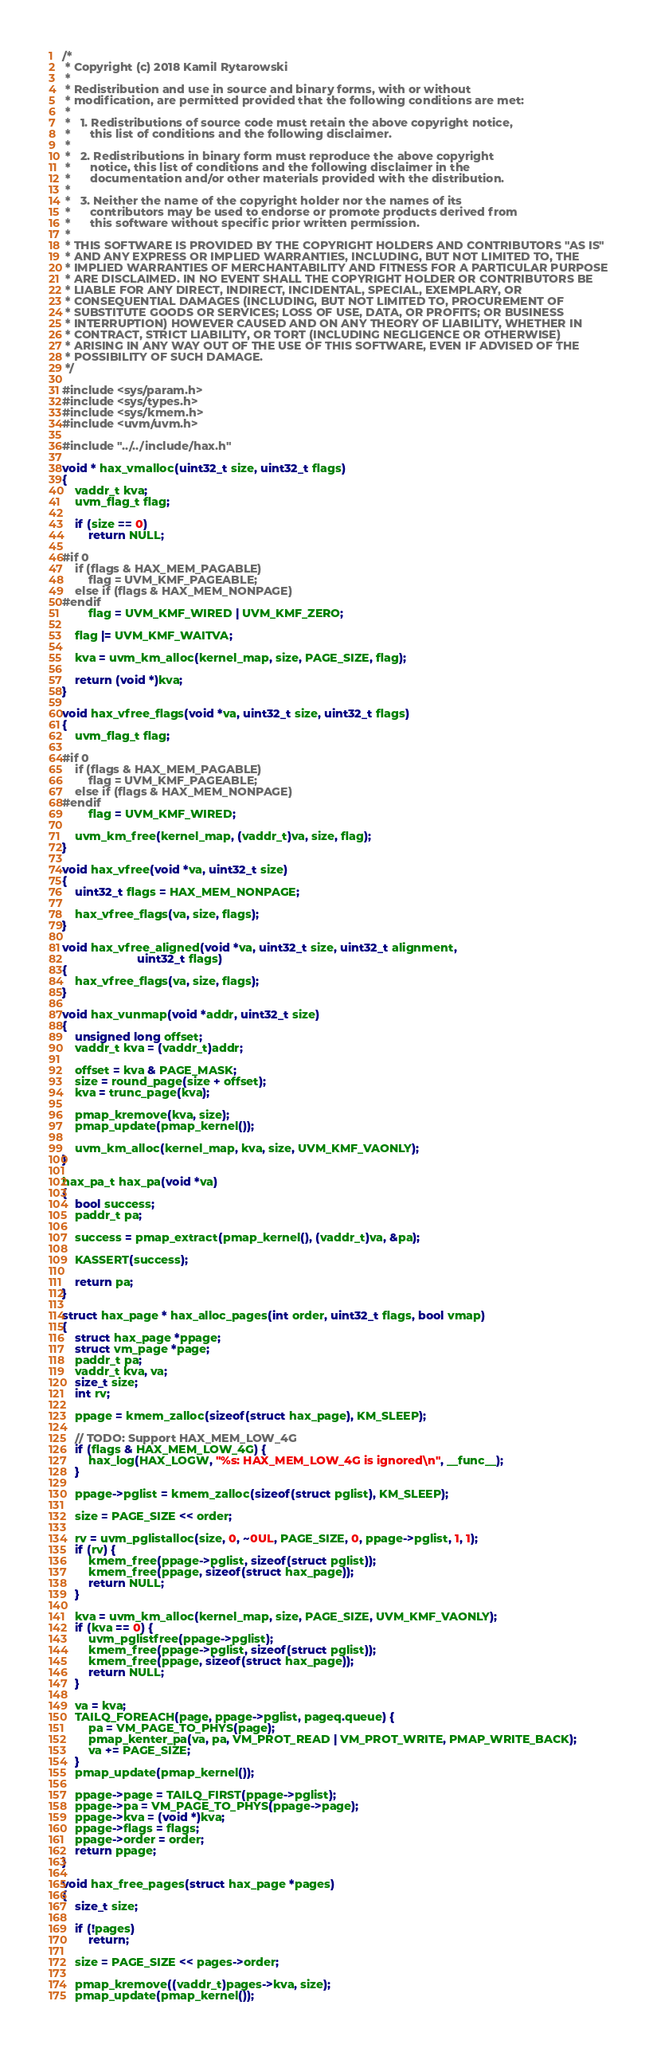Convert code to text. <code><loc_0><loc_0><loc_500><loc_500><_C_>/*
 * Copyright (c) 2018 Kamil Rytarowski
 *
 * Redistribution and use in source and binary forms, with or without
 * modification, are permitted provided that the following conditions are met:
 *
 *   1. Redistributions of source code must retain the above copyright notice,
 *      this list of conditions and the following disclaimer.
 *
 *   2. Redistributions in binary form must reproduce the above copyright
 *      notice, this list of conditions and the following disclaimer in the
 *      documentation and/or other materials provided with the distribution.
 *
 *   3. Neither the name of the copyright holder nor the names of its
 *      contributors may be used to endorse or promote products derived from
 *      this software without specific prior written permission.
 *
 * THIS SOFTWARE IS PROVIDED BY THE COPYRIGHT HOLDERS AND CONTRIBUTORS "AS IS"
 * AND ANY EXPRESS OR IMPLIED WARRANTIES, INCLUDING, BUT NOT LIMITED TO, THE
 * IMPLIED WARRANTIES OF MERCHANTABILITY AND FITNESS FOR A PARTICULAR PURPOSE
 * ARE DISCLAIMED. IN NO EVENT SHALL THE COPYRIGHT HOLDER OR CONTRIBUTORS BE
 * LIABLE FOR ANY DIRECT, INDIRECT, INCIDENTAL, SPECIAL, EXEMPLARY, OR
 * CONSEQUENTIAL DAMAGES (INCLUDING, BUT NOT LIMITED TO, PROCUREMENT OF
 * SUBSTITUTE GOODS OR SERVICES; LOSS OF USE, DATA, OR PROFITS; OR BUSINESS
 * INTERRUPTION) HOWEVER CAUSED AND ON ANY THEORY OF LIABILITY, WHETHER IN
 * CONTRACT, STRICT LIABILITY, OR TORT (INCLUDING NEGLIGENCE OR OTHERWISE)
 * ARISING IN ANY WAY OUT OF THE USE OF THIS SOFTWARE, EVEN IF ADVISED OF THE
 * POSSIBILITY OF SUCH DAMAGE.
 */

#include <sys/param.h>
#include <sys/types.h>
#include <sys/kmem.h>
#include <uvm/uvm.h>

#include "../../include/hax.h"

void * hax_vmalloc(uint32_t size, uint32_t flags)
{
    vaddr_t kva;
    uvm_flag_t flag;

    if (size == 0)
        return NULL;

#if 0
    if (flags & HAX_MEM_PAGABLE)
        flag = UVM_KMF_PAGEABLE;
    else if (flags & HAX_MEM_NONPAGE)
#endif
        flag = UVM_KMF_WIRED | UVM_KMF_ZERO;

    flag |= UVM_KMF_WAITVA;

    kva = uvm_km_alloc(kernel_map, size, PAGE_SIZE, flag);

    return (void *)kva;
}

void hax_vfree_flags(void *va, uint32_t size, uint32_t flags)
{
    uvm_flag_t flag;

#if 0
    if (flags & HAX_MEM_PAGABLE)
        flag = UVM_KMF_PAGEABLE;
    else if (flags & HAX_MEM_NONPAGE)
#endif
        flag = UVM_KMF_WIRED;

    uvm_km_free(kernel_map, (vaddr_t)va, size, flag);
}

void hax_vfree(void *va, uint32_t size)
{
    uint32_t flags = HAX_MEM_NONPAGE;

    hax_vfree_flags(va, size, flags);
}

void hax_vfree_aligned(void *va, uint32_t size, uint32_t alignment,
                       uint32_t flags)
{
    hax_vfree_flags(va, size, flags);
}

void hax_vunmap(void *addr, uint32_t size)
{
    unsigned long offset;
    vaddr_t kva = (vaddr_t)addr;

    offset = kva & PAGE_MASK;
    size = round_page(size + offset);
    kva = trunc_page(kva);

    pmap_kremove(kva, size);
    pmap_update(pmap_kernel());

    uvm_km_alloc(kernel_map, kva, size, UVM_KMF_VAONLY);
}

hax_pa_t hax_pa(void *va)
{
    bool success;
    paddr_t pa;

    success = pmap_extract(pmap_kernel(), (vaddr_t)va, &pa);

    KASSERT(success);

    return pa;
}

struct hax_page * hax_alloc_pages(int order, uint32_t flags, bool vmap)
{
    struct hax_page *ppage;
    struct vm_page *page;
    paddr_t pa;
    vaddr_t kva, va;
    size_t size;
    int rv;

    ppage = kmem_zalloc(sizeof(struct hax_page), KM_SLEEP);

    // TODO: Support HAX_MEM_LOW_4G
    if (flags & HAX_MEM_LOW_4G) {
        hax_log(HAX_LOGW, "%s: HAX_MEM_LOW_4G is ignored\n", __func__);
    }

    ppage->pglist = kmem_zalloc(sizeof(struct pglist), KM_SLEEP);

    size = PAGE_SIZE << order;

    rv = uvm_pglistalloc(size, 0, ~0UL, PAGE_SIZE, 0, ppage->pglist, 1, 1);
    if (rv) {
        kmem_free(ppage->pglist, sizeof(struct pglist));
        kmem_free(ppage, sizeof(struct hax_page));
        return NULL;
    }

    kva = uvm_km_alloc(kernel_map, size, PAGE_SIZE, UVM_KMF_VAONLY);
    if (kva == 0) {
        uvm_pglistfree(ppage->pglist);
        kmem_free(ppage->pglist, sizeof(struct pglist));
        kmem_free(ppage, sizeof(struct hax_page));
        return NULL;
    }

    va = kva;
    TAILQ_FOREACH(page, ppage->pglist, pageq.queue) {
        pa = VM_PAGE_TO_PHYS(page);
        pmap_kenter_pa(va, pa, VM_PROT_READ | VM_PROT_WRITE, PMAP_WRITE_BACK);
        va += PAGE_SIZE;
    }
    pmap_update(pmap_kernel());

    ppage->page = TAILQ_FIRST(ppage->pglist);
    ppage->pa = VM_PAGE_TO_PHYS(ppage->page);
    ppage->kva = (void *)kva;
    ppage->flags = flags;
    ppage->order = order;
    return ppage;
}

void hax_free_pages(struct hax_page *pages)
{
    size_t size;

    if (!pages)
        return;

    size = PAGE_SIZE << pages->order;

    pmap_kremove((vaddr_t)pages->kva, size);
    pmap_update(pmap_kernel());</code> 